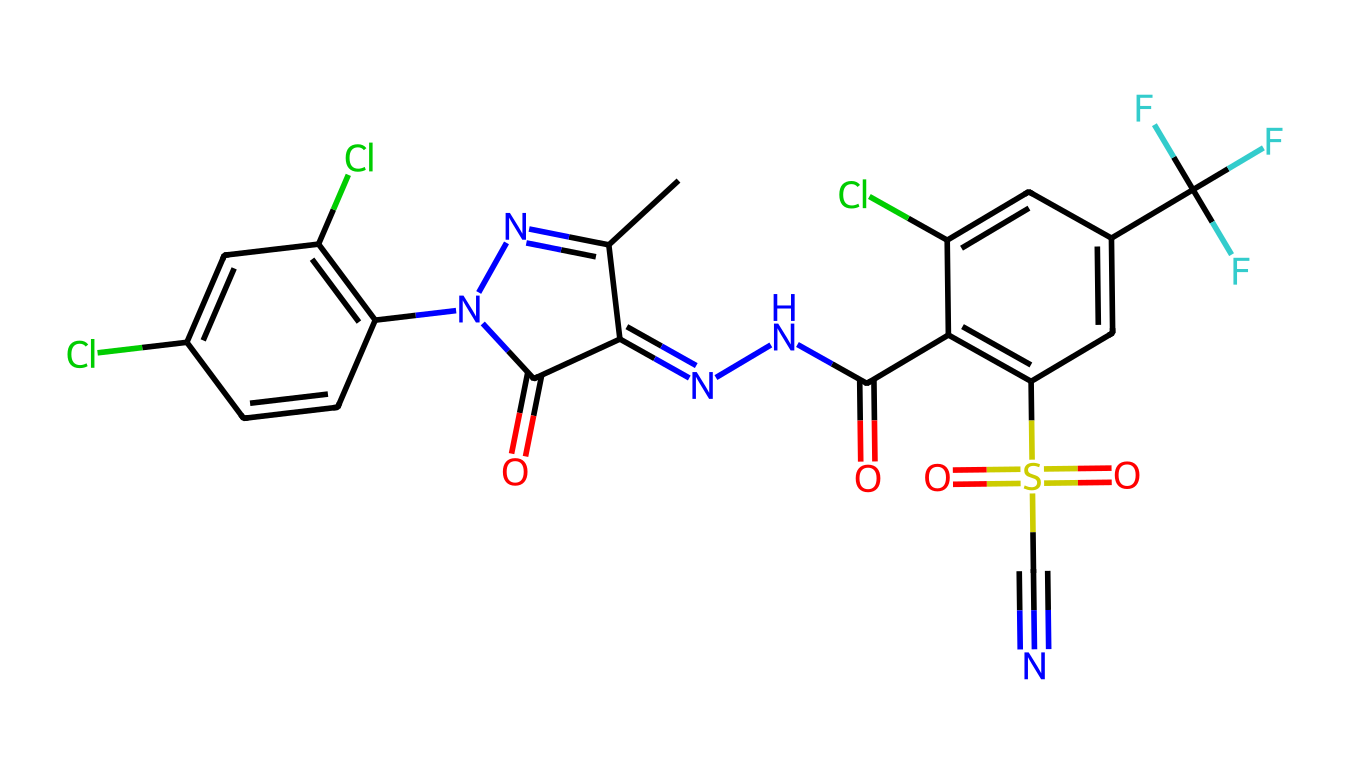What is the primary functional group present in fipronil? The primary functional group in fipronil is the sulfonyl group, represented by the S(=O)(=O) part, connected to other parts of the molecule through the sulfur atom.
Answer: sulfonyl How many chlorine atoms are present in the compound? By examining the structure, two chlorine atoms are indicated by the Cl labels attached to different aromatic rings in the chemical.
Answer: 2 What type of compound is fipronil categorized as? Fipronil is categorized as a phenylpyrazole, which is a class of insecticides, identifiable by its unique structural components including the pyrazole ring and the phenyl moiety.
Answer: insecticide How many rings are present in the molecular structure? Upon reviewing the structure, there are three distinct rings: two aromatic (benzene) rings and one pyrazole ring, making a total of three rings in the molecule.
Answer: 3 What is the total number of nitrogen atoms in fipronil? Analyzing the structure shows that there are four nitrogen atoms distributed throughout the molecule, including the parts of the pyrazole and amidine structures.
Answer: 4 Does fipronil contain any fluorine atoms? The presence of trifluoromethyl (represented by C(F)(F)F) in the molecular structure indicates that there are three fluorine atoms attached to the carbon.
Answer: 3 